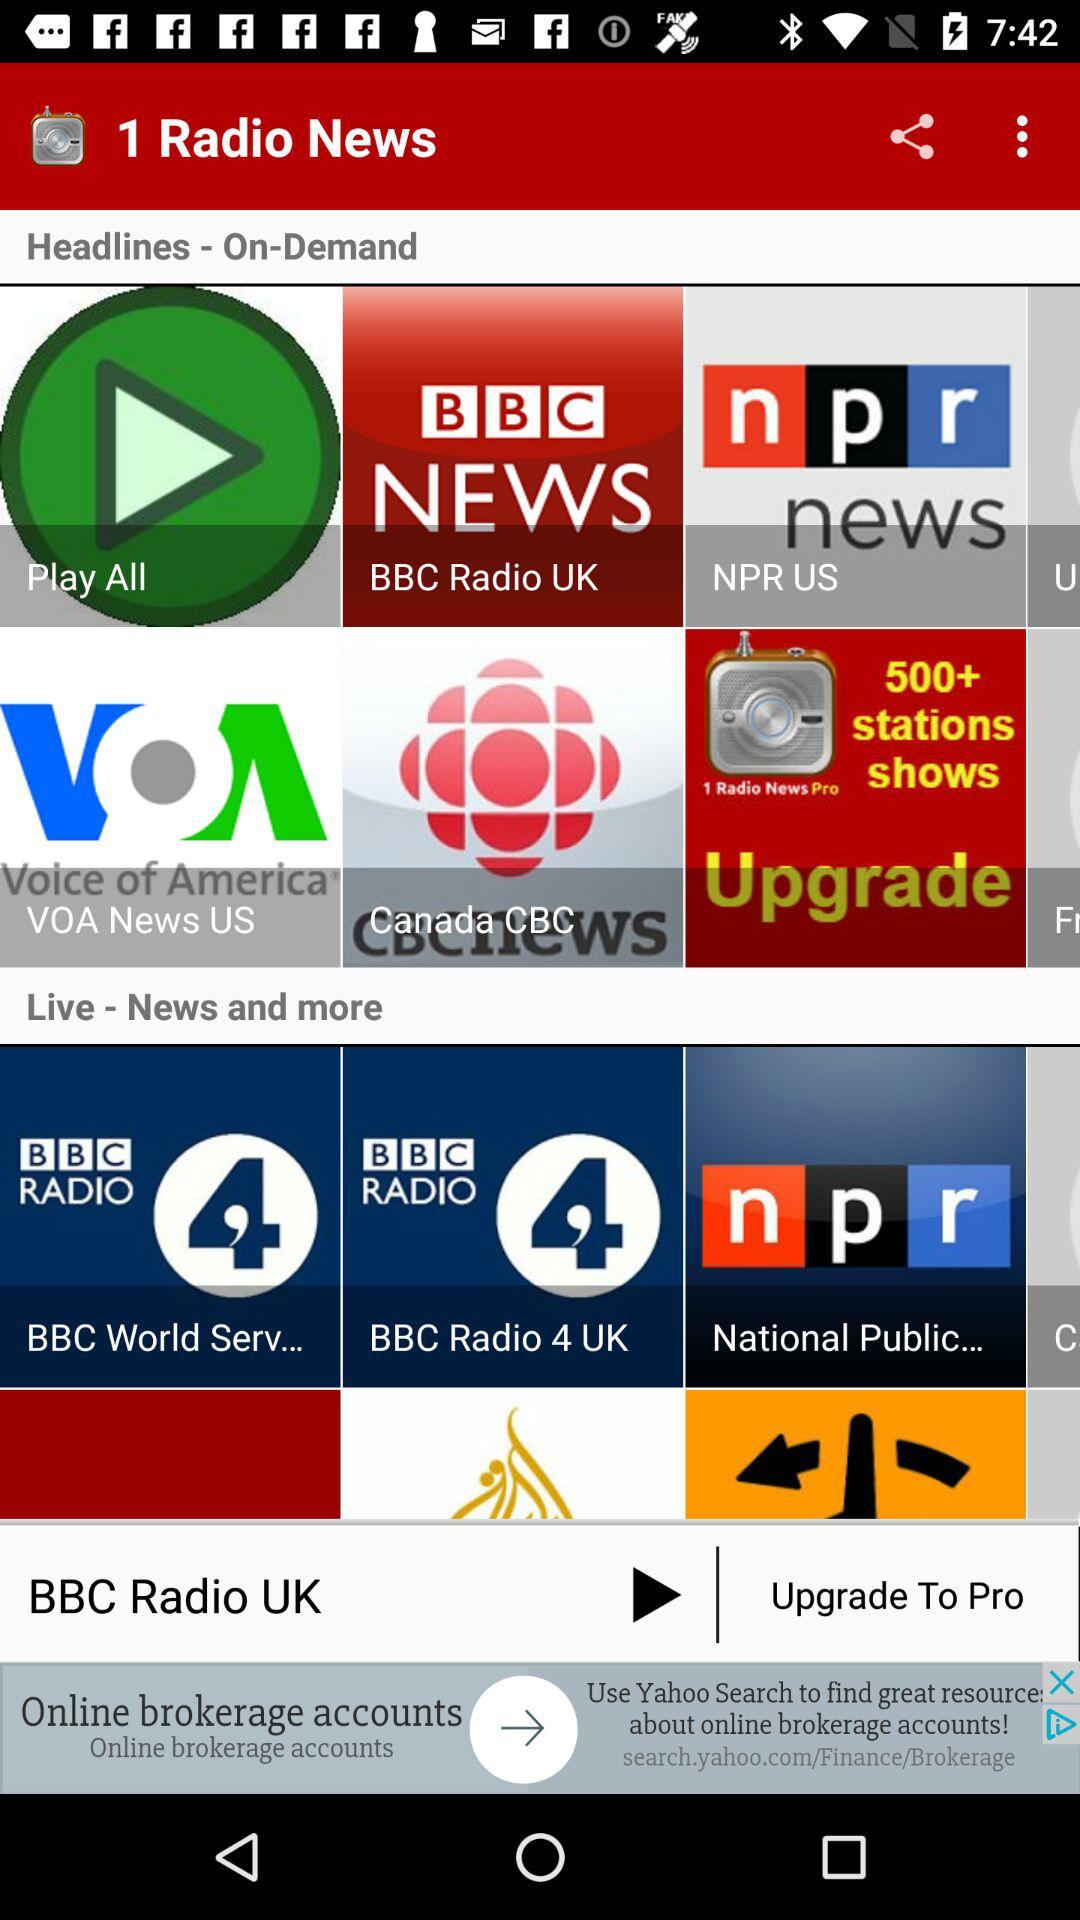What is the application name? The application name is "1 Radio News". 